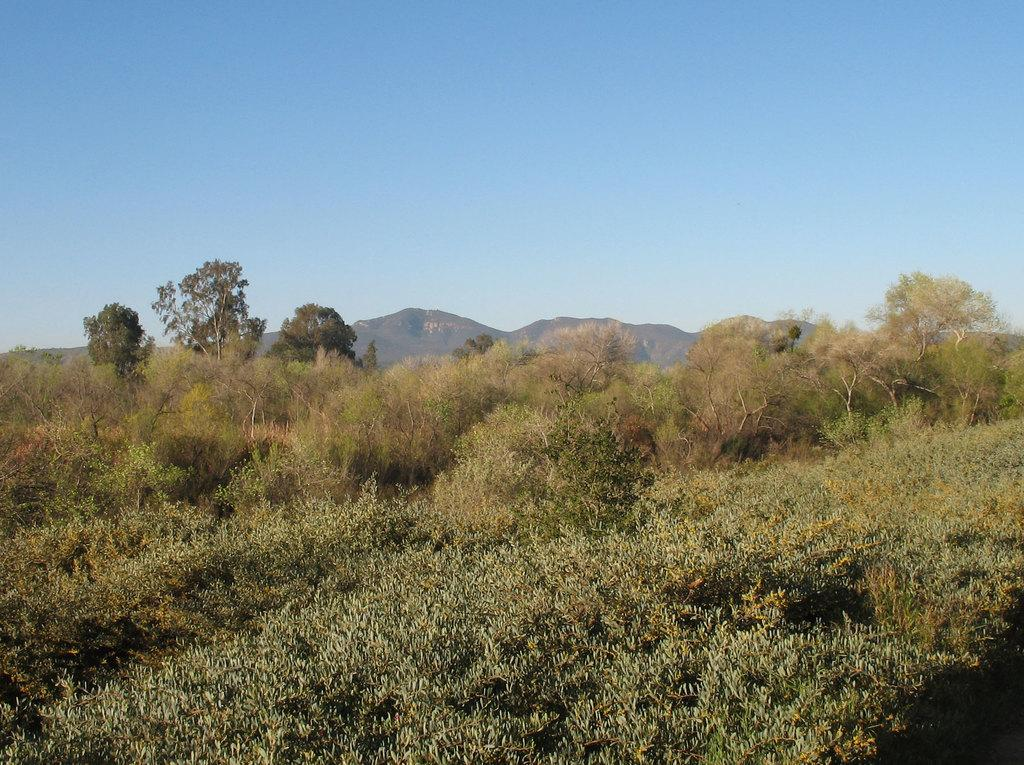What type of vegetation is in the front of the image? There are plants in the front of the image. What can be seen in the background of the image? There are trees and a hill in the background of the image. What is visible at the top of the image? The sky is visible at the top of the image. What type of quartz can be seen in the image? There is no quartz present in the image. How do the waves interact with the plants in the image? There are no waves present in the image; it features plants, trees, a hill, and the sky. 